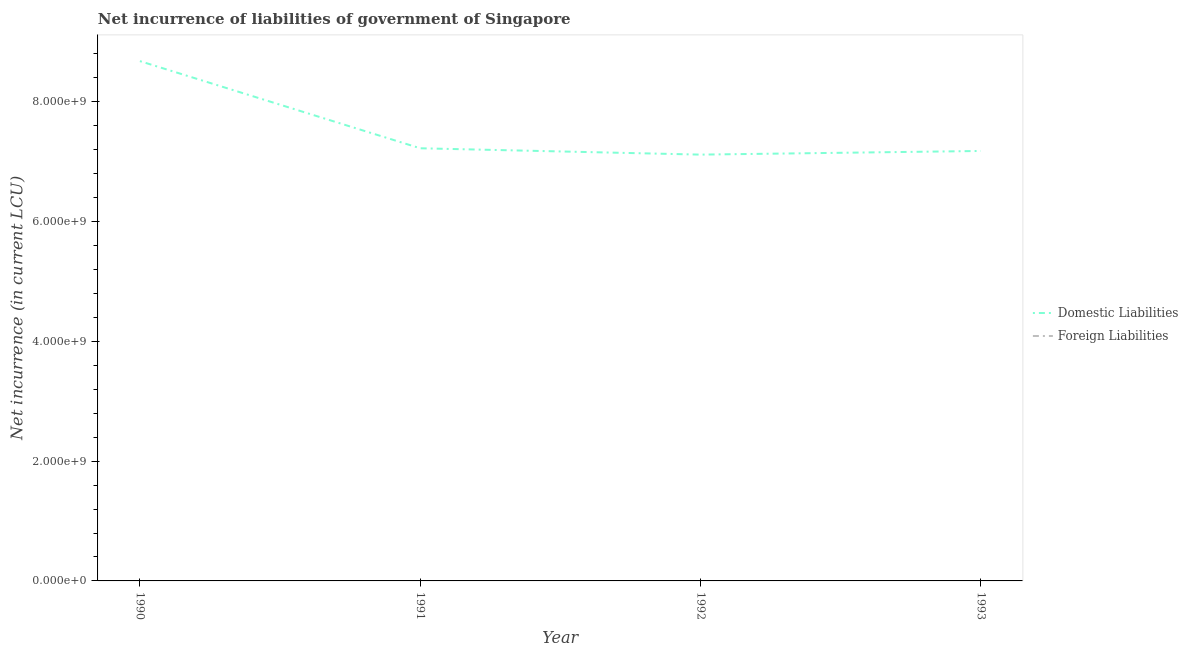Does the line corresponding to net incurrence of domestic liabilities intersect with the line corresponding to net incurrence of foreign liabilities?
Offer a very short reply. No. Is the number of lines equal to the number of legend labels?
Provide a short and direct response. No. What is the net incurrence of domestic liabilities in 1992?
Offer a terse response. 7.12e+09. Across all years, what is the maximum net incurrence of domestic liabilities?
Keep it short and to the point. 8.68e+09. Across all years, what is the minimum net incurrence of domestic liabilities?
Make the answer very short. 7.12e+09. In which year was the net incurrence of domestic liabilities maximum?
Keep it short and to the point. 1990. What is the difference between the net incurrence of domestic liabilities in 1990 and that in 1993?
Provide a short and direct response. 1.50e+09. What is the difference between the net incurrence of domestic liabilities in 1992 and the net incurrence of foreign liabilities in 1990?
Provide a succinct answer. 7.12e+09. What is the average net incurrence of foreign liabilities per year?
Provide a short and direct response. 0. In how many years, is the net incurrence of foreign liabilities greater than 6400000000 LCU?
Your response must be concise. 0. What is the ratio of the net incurrence of domestic liabilities in 1990 to that in 1991?
Give a very brief answer. 1.2. What is the difference between the highest and the second highest net incurrence of domestic liabilities?
Ensure brevity in your answer.  1.46e+09. Is the net incurrence of foreign liabilities strictly less than the net incurrence of domestic liabilities over the years?
Provide a short and direct response. Yes. How many lines are there?
Provide a succinct answer. 1. How many years are there in the graph?
Provide a succinct answer. 4. Are the values on the major ticks of Y-axis written in scientific E-notation?
Give a very brief answer. Yes. Does the graph contain any zero values?
Your answer should be compact. Yes. Where does the legend appear in the graph?
Ensure brevity in your answer.  Center right. How many legend labels are there?
Provide a succinct answer. 2. How are the legend labels stacked?
Keep it short and to the point. Vertical. What is the title of the graph?
Keep it short and to the point. Net incurrence of liabilities of government of Singapore. What is the label or title of the X-axis?
Provide a succinct answer. Year. What is the label or title of the Y-axis?
Your answer should be compact. Net incurrence (in current LCU). What is the Net incurrence (in current LCU) of Domestic Liabilities in 1990?
Your response must be concise. 8.68e+09. What is the Net incurrence (in current LCU) of Foreign Liabilities in 1990?
Offer a terse response. 0. What is the Net incurrence (in current LCU) of Domestic Liabilities in 1991?
Make the answer very short. 7.22e+09. What is the Net incurrence (in current LCU) of Domestic Liabilities in 1992?
Your answer should be compact. 7.12e+09. What is the Net incurrence (in current LCU) of Domestic Liabilities in 1993?
Offer a very short reply. 7.18e+09. What is the Net incurrence (in current LCU) in Foreign Liabilities in 1993?
Your answer should be compact. 0. Across all years, what is the maximum Net incurrence (in current LCU) of Domestic Liabilities?
Offer a terse response. 8.68e+09. Across all years, what is the minimum Net incurrence (in current LCU) of Domestic Liabilities?
Your answer should be compact. 7.12e+09. What is the total Net incurrence (in current LCU) of Domestic Liabilities in the graph?
Provide a succinct answer. 3.02e+1. What is the total Net incurrence (in current LCU) in Foreign Liabilities in the graph?
Your answer should be compact. 0. What is the difference between the Net incurrence (in current LCU) in Domestic Liabilities in 1990 and that in 1991?
Your answer should be compact. 1.46e+09. What is the difference between the Net incurrence (in current LCU) of Domestic Liabilities in 1990 and that in 1992?
Provide a short and direct response. 1.56e+09. What is the difference between the Net incurrence (in current LCU) of Domestic Liabilities in 1990 and that in 1993?
Offer a terse response. 1.50e+09. What is the difference between the Net incurrence (in current LCU) of Domestic Liabilities in 1991 and that in 1992?
Make the answer very short. 1.06e+08. What is the difference between the Net incurrence (in current LCU) of Domestic Liabilities in 1991 and that in 1993?
Offer a terse response. 4.50e+07. What is the difference between the Net incurrence (in current LCU) in Domestic Liabilities in 1992 and that in 1993?
Make the answer very short. -6.10e+07. What is the average Net incurrence (in current LCU) in Domestic Liabilities per year?
Ensure brevity in your answer.  7.55e+09. What is the ratio of the Net incurrence (in current LCU) of Domestic Liabilities in 1990 to that in 1991?
Ensure brevity in your answer.  1.2. What is the ratio of the Net incurrence (in current LCU) of Domestic Liabilities in 1990 to that in 1992?
Keep it short and to the point. 1.22. What is the ratio of the Net incurrence (in current LCU) of Domestic Liabilities in 1990 to that in 1993?
Ensure brevity in your answer.  1.21. What is the ratio of the Net incurrence (in current LCU) of Domestic Liabilities in 1991 to that in 1992?
Ensure brevity in your answer.  1.01. What is the ratio of the Net incurrence (in current LCU) in Domestic Liabilities in 1992 to that in 1993?
Offer a very short reply. 0.99. What is the difference between the highest and the second highest Net incurrence (in current LCU) of Domestic Liabilities?
Ensure brevity in your answer.  1.46e+09. What is the difference between the highest and the lowest Net incurrence (in current LCU) in Domestic Liabilities?
Offer a very short reply. 1.56e+09. 